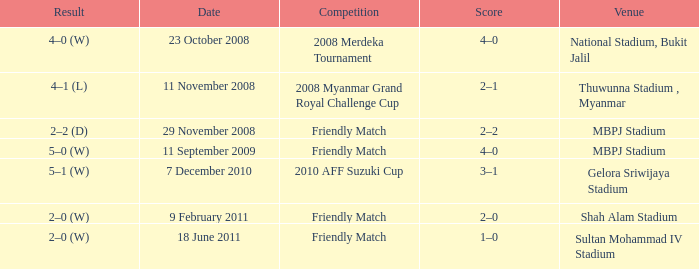What Competition had a Score of 2–0? Friendly Match. 